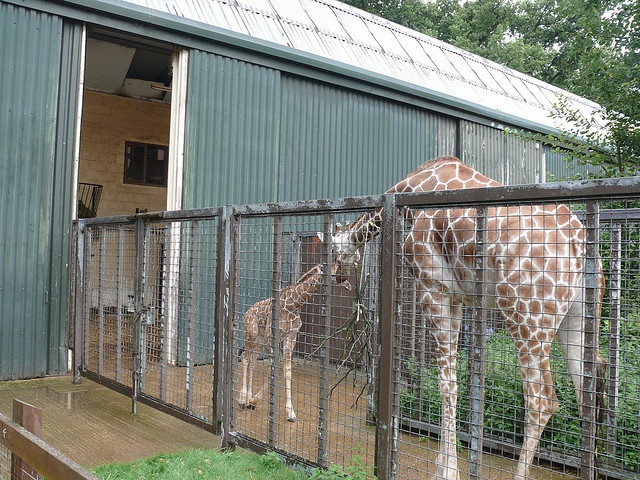Describe the objects in this image and their specific colors. I can see giraffe in black, darkgray, lightgray, gray, and tan tones and giraffe in black, gray, and darkgray tones in this image. 